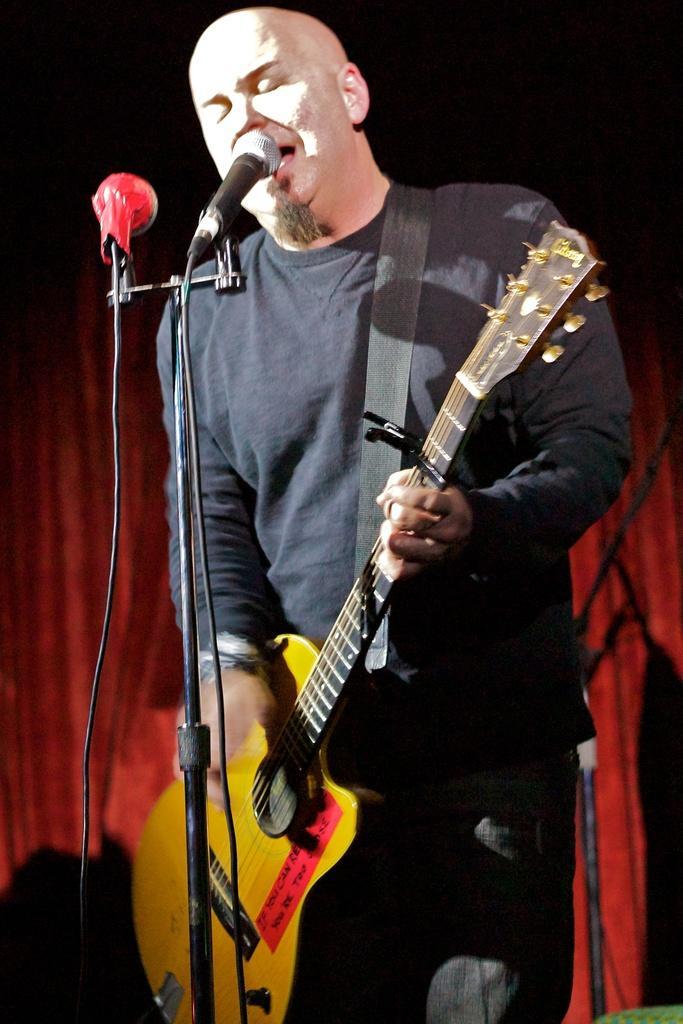How would you summarize this image in a sentence or two? In this image I see a man who is holding a guitar and is in front of a mic. 